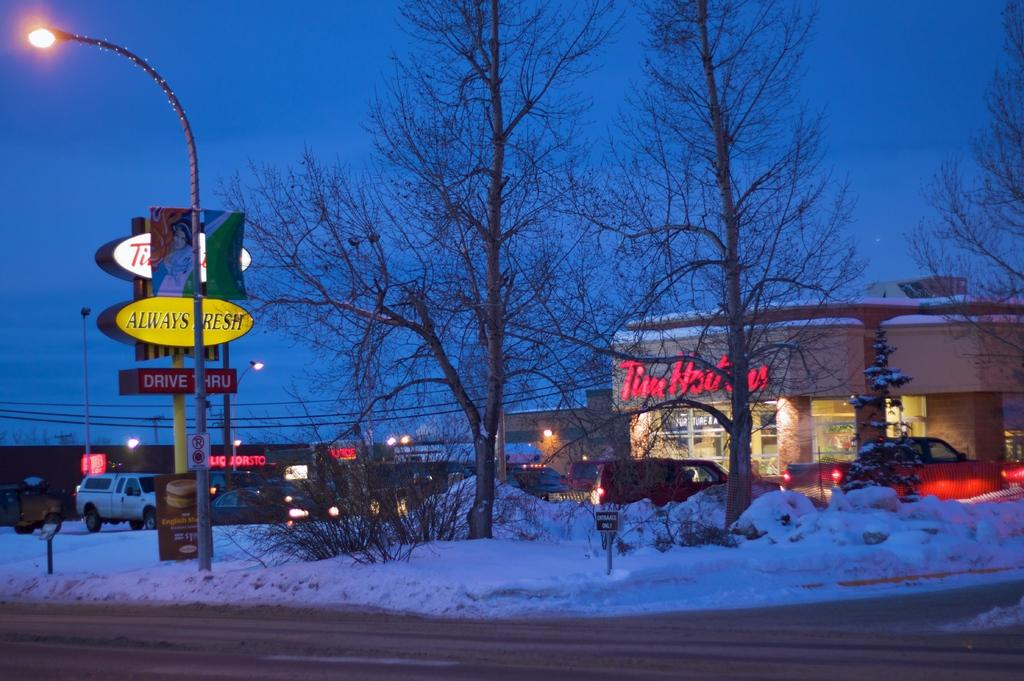<image>
Give a short and clear explanation of the subsequent image. A yellow sign in front of a Tim Hortons says it is always fresh. 